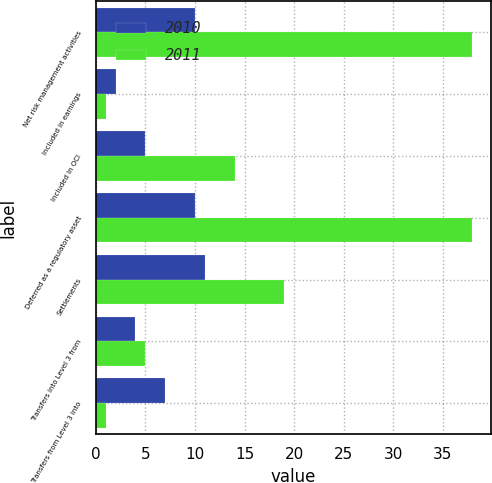<chart> <loc_0><loc_0><loc_500><loc_500><stacked_bar_chart><ecel><fcel>Net risk management activities<fcel>Included in earnings<fcel>Included in OCI<fcel>Deferred as a regulatory asset<fcel>Settlements<fcel>Transfers into Level 3 from<fcel>Transfers from Level 3 into<nl><fcel>2010<fcel>10<fcel>2<fcel>5<fcel>10<fcel>11<fcel>4<fcel>7<nl><fcel>2011<fcel>38<fcel>1<fcel>14<fcel>38<fcel>19<fcel>5<fcel>1<nl></chart> 